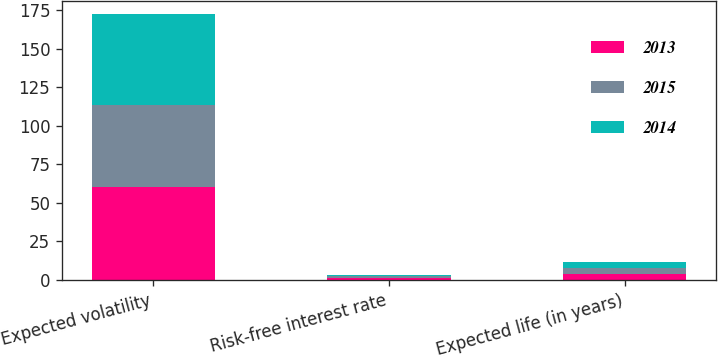Convert chart to OTSL. <chart><loc_0><loc_0><loc_500><loc_500><stacked_bar_chart><ecel><fcel>Expected volatility<fcel>Risk-free interest rate<fcel>Expected life (in years)<nl><fcel>2013<fcel>60.14<fcel>1.29<fcel>3.91<nl><fcel>2015<fcel>53.36<fcel>1.15<fcel>3.86<nl><fcel>2014<fcel>59.03<fcel>0.79<fcel>3.83<nl></chart> 